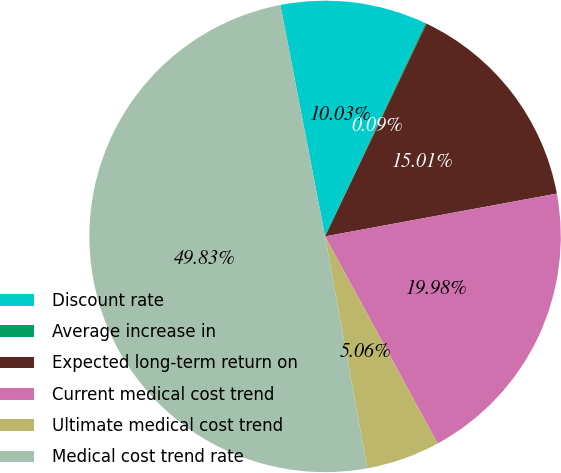<chart> <loc_0><loc_0><loc_500><loc_500><pie_chart><fcel>Discount rate<fcel>Average increase in<fcel>Expected long-term return on<fcel>Current medical cost trend<fcel>Ultimate medical cost trend<fcel>Medical cost trend rate<nl><fcel>10.03%<fcel>0.09%<fcel>15.01%<fcel>19.98%<fcel>5.06%<fcel>49.83%<nl></chart> 